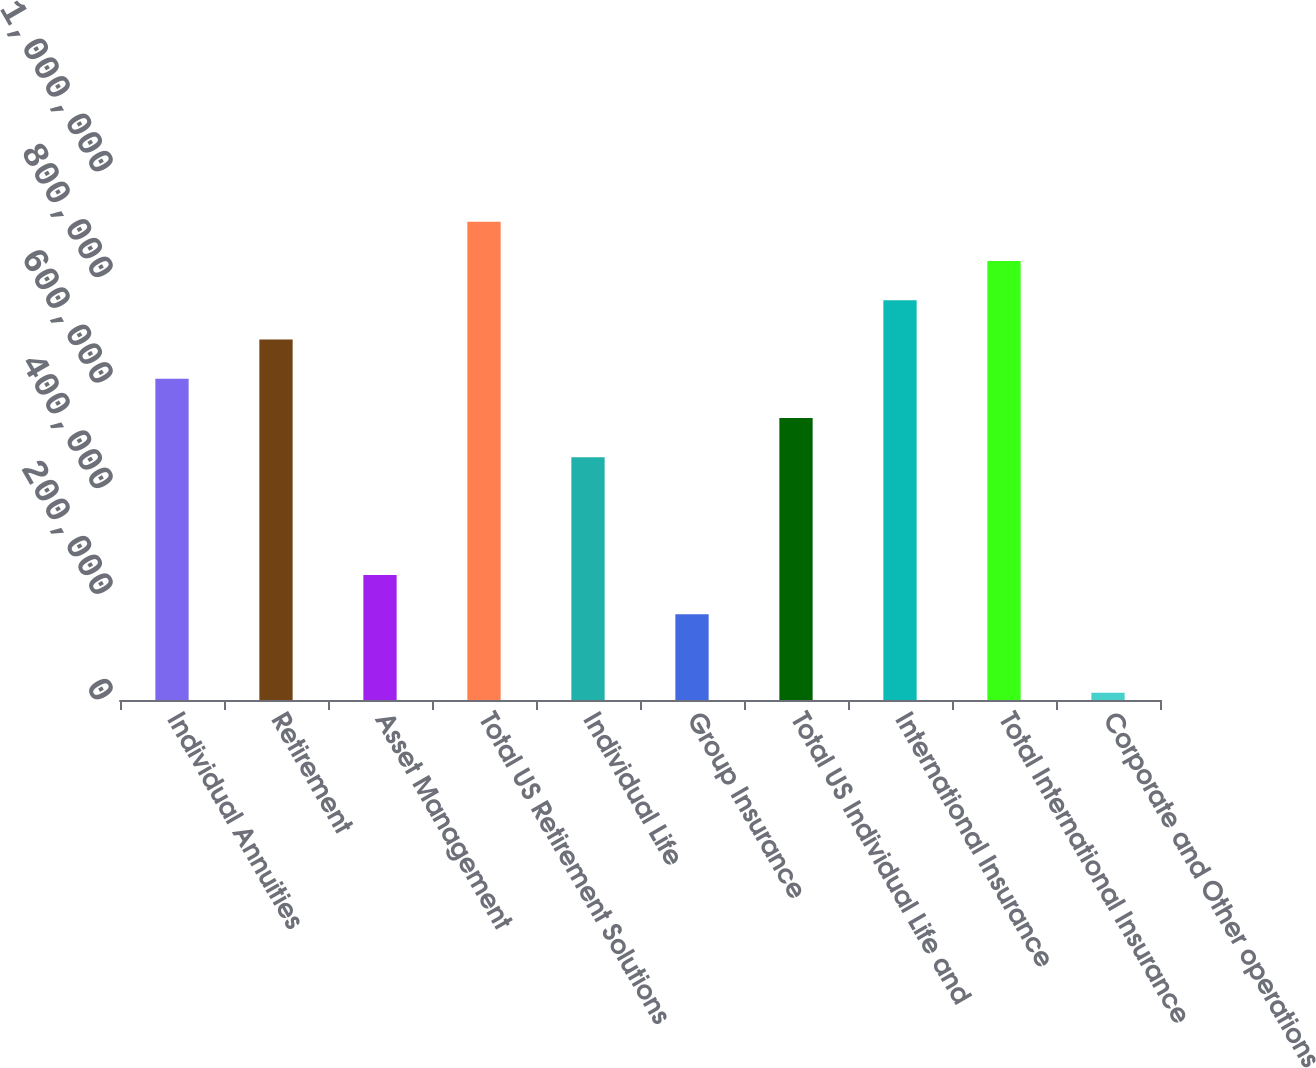Convert chart. <chart><loc_0><loc_0><loc_500><loc_500><bar_chart><fcel>Individual Annuities<fcel>Retirement<fcel>Asset Management<fcel>Total US Retirement Solutions<fcel>Individual Life<fcel>Group Insurance<fcel>Total US Individual Life and<fcel>International Insurance<fcel>Total International Insurance<fcel>Corporate and Other operations<nl><fcel>608535<fcel>682895<fcel>236734<fcel>905975<fcel>459815<fcel>162374<fcel>534175<fcel>757255<fcel>831615<fcel>13654<nl></chart> 